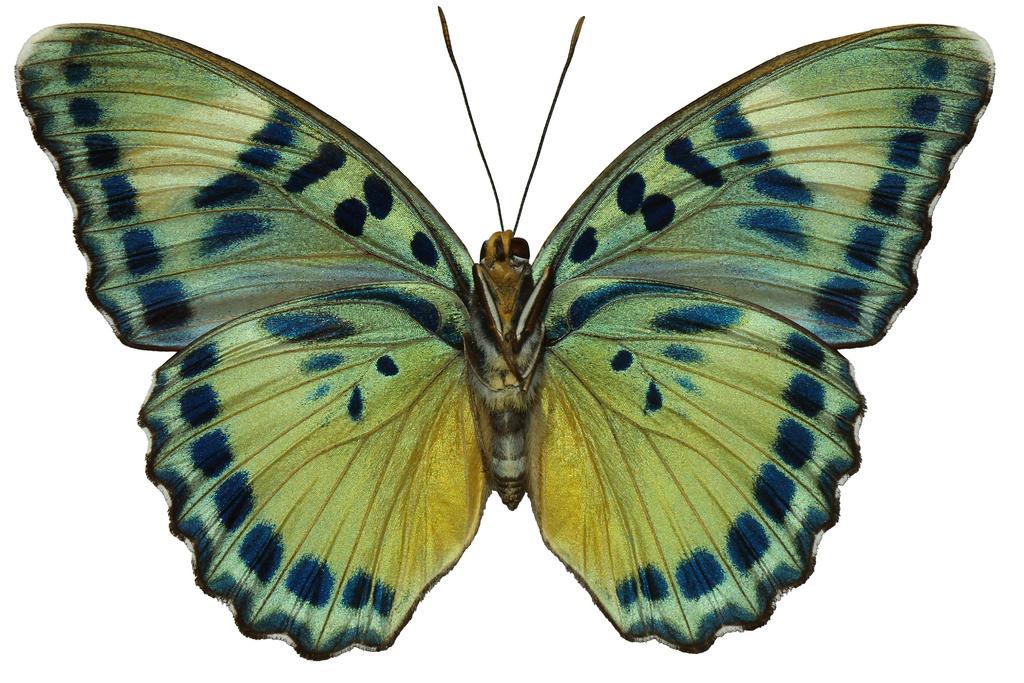How would you summarize this image in a sentence or two? In the image there is a butterfly in the front and the background is white. 